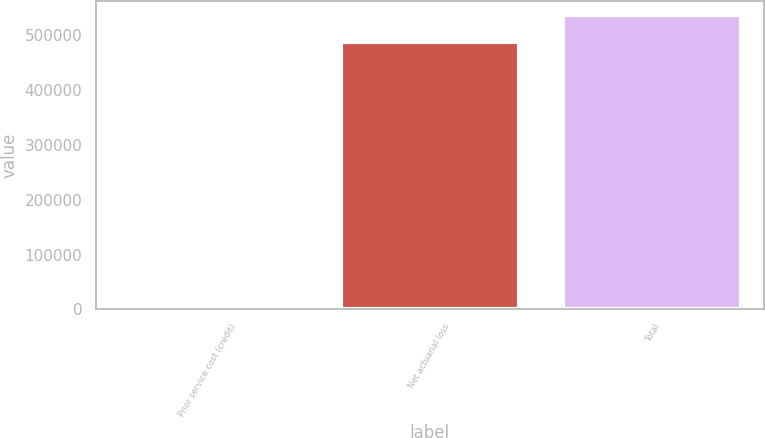<chart> <loc_0><loc_0><loc_500><loc_500><bar_chart><fcel>Prior service cost (credit)<fcel>Net actuarial loss<fcel>Total<nl><fcel>1685<fcel>488080<fcel>536888<nl></chart> 